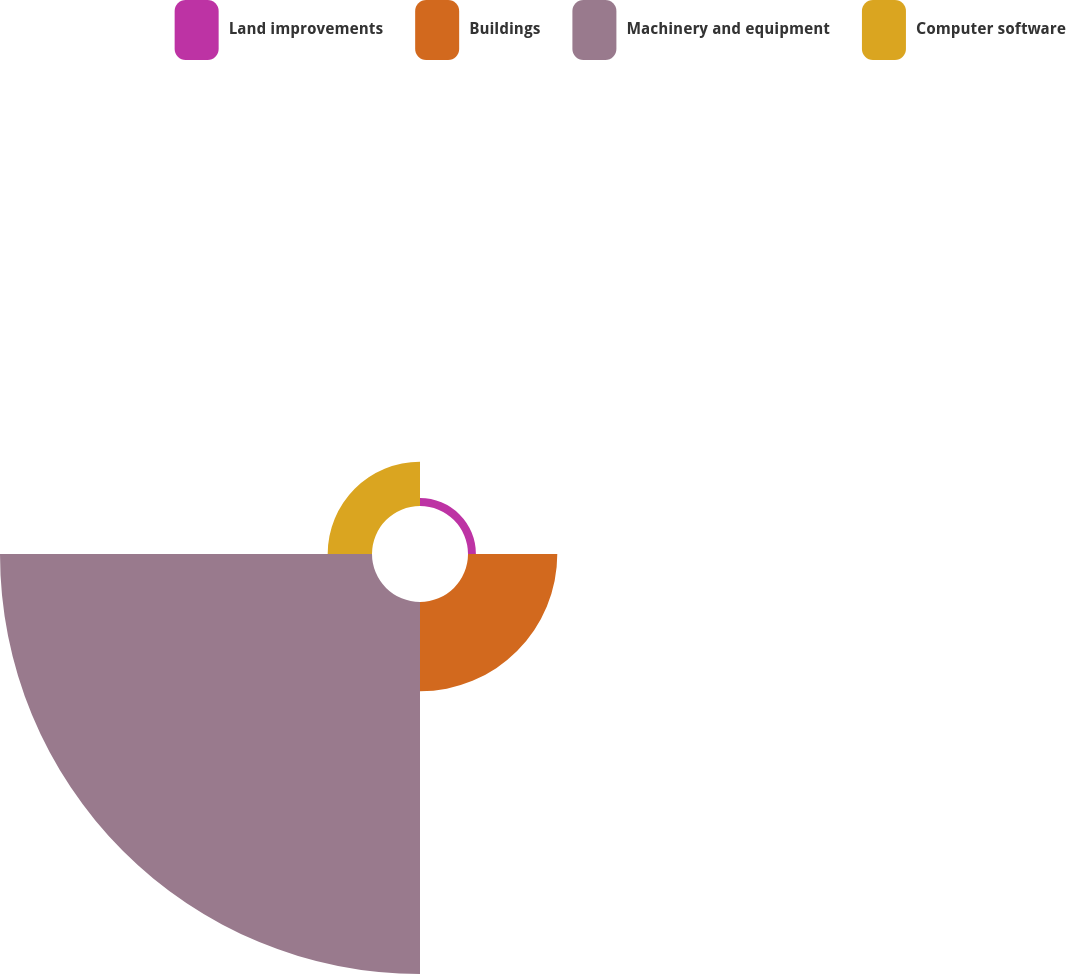<chart> <loc_0><loc_0><loc_500><loc_500><pie_chart><fcel>Land improvements<fcel>Buildings<fcel>Machinery and equipment<fcel>Computer software<nl><fcel>1.54%<fcel>17.39%<fcel>72.45%<fcel>8.63%<nl></chart> 